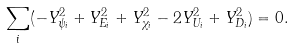Convert formula to latex. <formula><loc_0><loc_0><loc_500><loc_500>\sum _ { i } ( - Y ^ { 2 } _ { \psi _ { i } } + Y ^ { 2 } _ { E _ { i } } + Y ^ { 2 } _ { \chi _ { i } } - 2 Y ^ { 2 } _ { U _ { i } } + Y ^ { 2 } _ { D _ { i } } ) = 0 .</formula> 